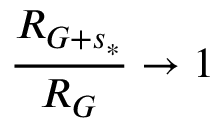<formula> <loc_0><loc_0><loc_500><loc_500>\frac { R _ { G + s _ { * } } } { R _ { G } } \rightarrow 1</formula> 